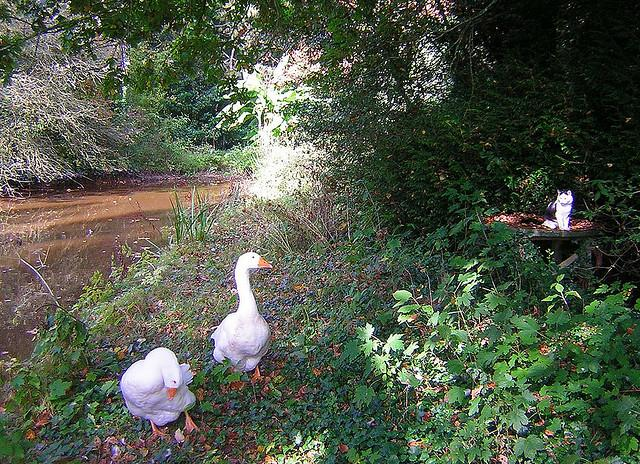Where is the cat staring to?

Choices:
A) ducks
B) down
C) right
D) up ducks 